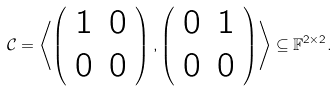Convert formula to latex. <formula><loc_0><loc_0><loc_500><loc_500>\mathcal { C } = \left \langle \left ( \begin{array} { c c } 1 & 0 \\ 0 & 0 \end{array} \right ) , \left ( \begin{array} { c c } 0 & 1 \\ 0 & 0 \end{array} \right ) \right \rangle \subseteq \mathbb { F } ^ { 2 \times 2 } .</formula> 